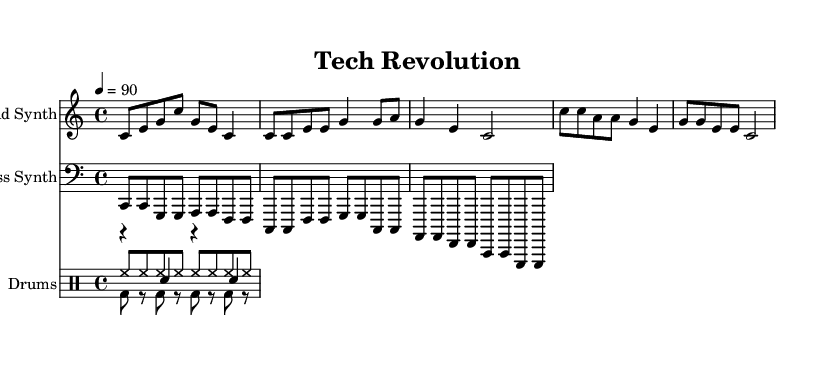what is the key signature of this music? The key signature indicated at the beginning of the score is C major, which contains no sharps or flats. This is visible in the key signature symbol that appears at the start of the staff.
Answer: C major what is the time signature of this music? The time signature shown at the beginning of the score is 4/4, which means there are four beats in each measure and the quarter note receives one beat. This is represented directly following the key signature.
Answer: 4/4 what is the tempo of this music? The tempo marking in the score indicates a speed of 90 beats per minute (BPM). This is specified in the tempo directive at the beginning of the piece.
Answer: 90 how many measures are in the lead synth section? Counting the measures in the lead synth part, there are a total of six measures present in this section. This is determined by identifying the bar lines that separate the measures throughout the music.
Answer: 6 which instrument plays the bass line? The instrument designated to play the bass line is referred to as the "Bass Synth" in the score. This is clearly marked above the corresponding staff that displays the bass notes.
Answer: Bass Synth what is the rhythmic pattern used in the drum kick? The drum kick follows a consistent pattern of bass drum hits that occur on the first beat of every measure and are indicated in the drum notation as 'bd' for bass drum. This pattern is repeated throughout the section.
Answer: bd8 which section of the piece corresponds to the chorus? The chorus section is identifiable as it features a different musical idea and is marked by a change in the note pattern; it's typically discernible by the distinct outline of the notes used and their arrangement in the score.
Answer: Chorus 